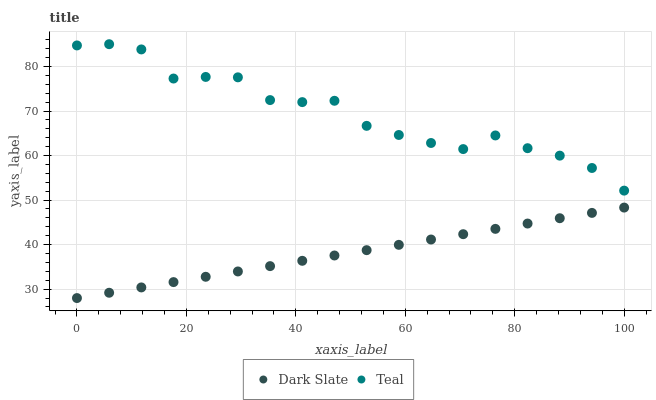Does Dark Slate have the minimum area under the curve?
Answer yes or no. Yes. Does Teal have the maximum area under the curve?
Answer yes or no. Yes. Does Teal have the minimum area under the curve?
Answer yes or no. No. Is Dark Slate the smoothest?
Answer yes or no. Yes. Is Teal the roughest?
Answer yes or no. Yes. Is Teal the smoothest?
Answer yes or no. No. Does Dark Slate have the lowest value?
Answer yes or no. Yes. Does Teal have the lowest value?
Answer yes or no. No. Does Teal have the highest value?
Answer yes or no. Yes. Is Dark Slate less than Teal?
Answer yes or no. Yes. Is Teal greater than Dark Slate?
Answer yes or no. Yes. Does Dark Slate intersect Teal?
Answer yes or no. No. 